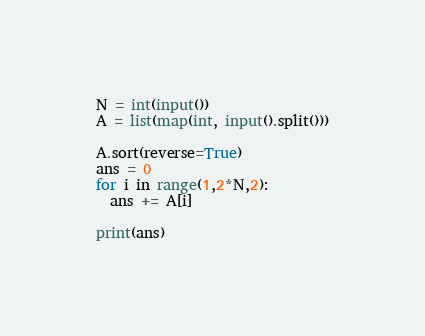<code> <loc_0><loc_0><loc_500><loc_500><_Python_>N = int(input())
A = list(map(int, input().split()))

A.sort(reverse=True)
ans = 0
for i in range(1,2*N,2):
  ans += A[i]
  
print(ans)</code> 